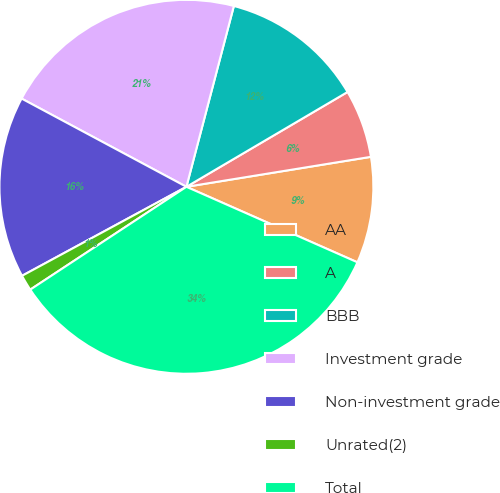Convert chart to OTSL. <chart><loc_0><loc_0><loc_500><loc_500><pie_chart><fcel>AA<fcel>A<fcel>BBB<fcel>Investment grade<fcel>Non-investment grade<fcel>Unrated(2)<fcel>Total<nl><fcel>9.18%<fcel>5.9%<fcel>12.45%<fcel>21.26%<fcel>15.72%<fcel>1.37%<fcel>34.11%<nl></chart> 